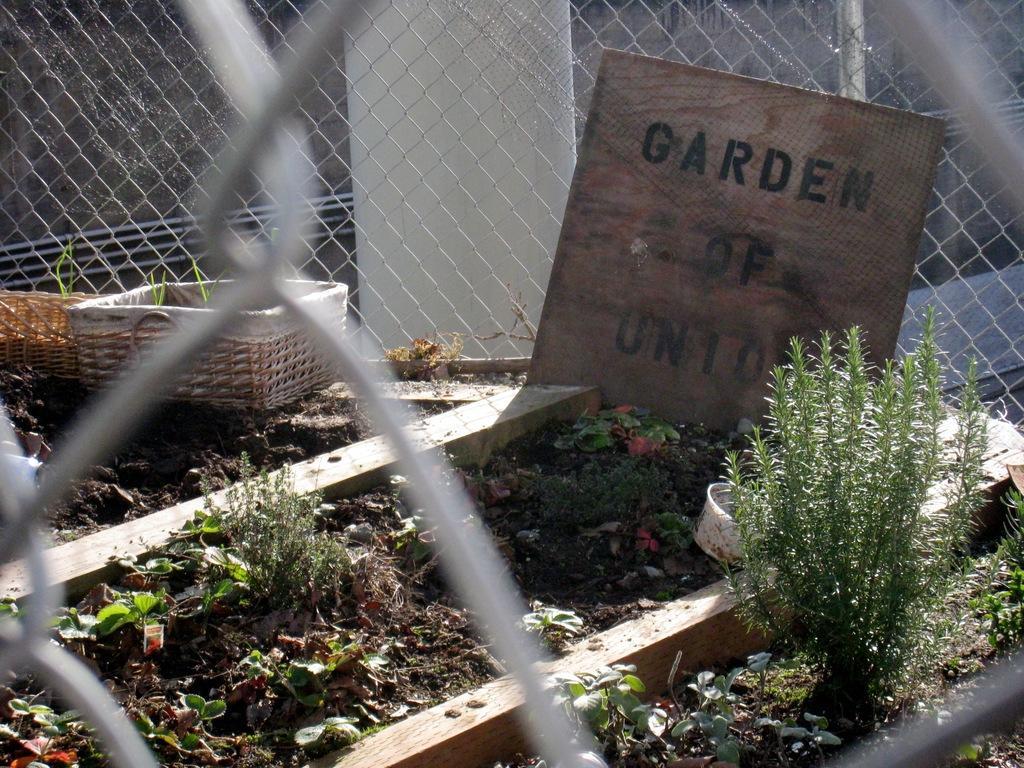Could you give a brief overview of what you see in this image? In this image I can see a board and something is written on it. We can see a basket and small plants. Back I can see iron net. 